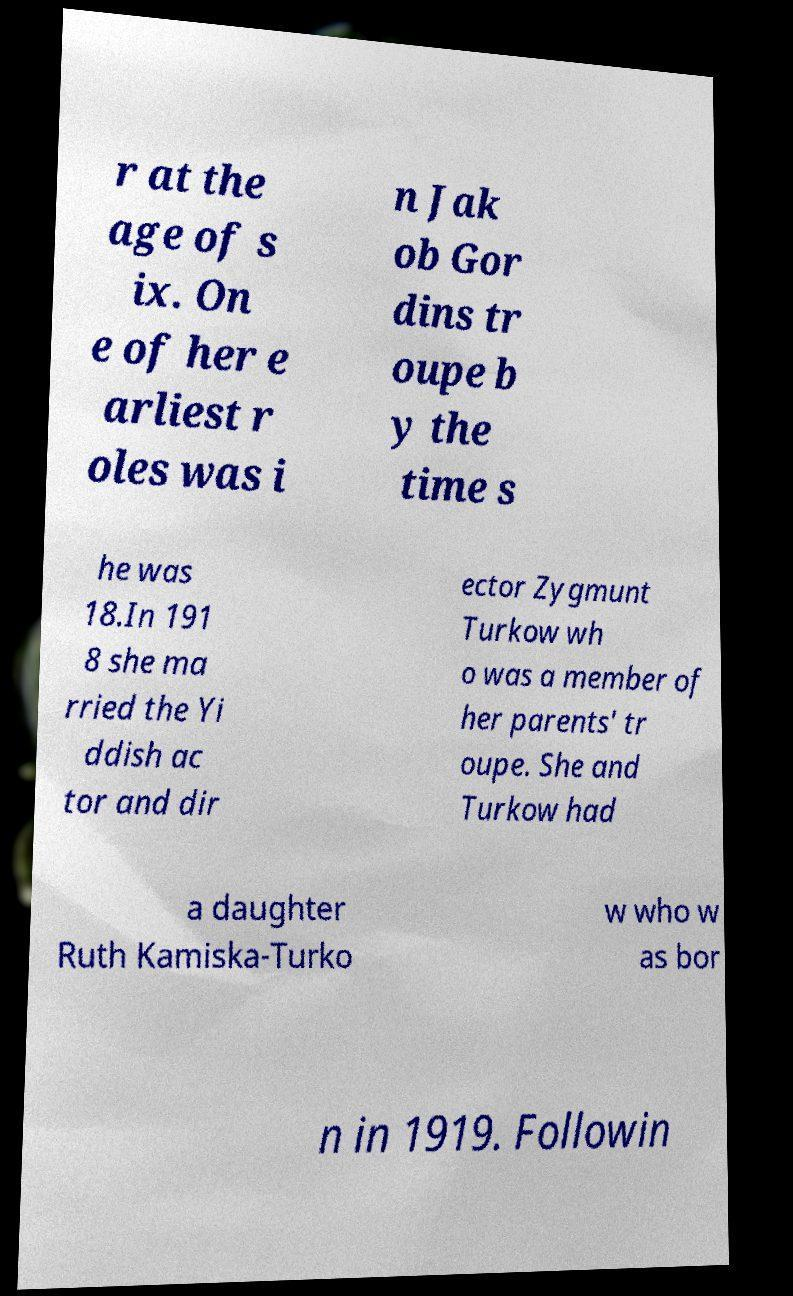Please read and relay the text visible in this image. What does it say? r at the age of s ix. On e of her e arliest r oles was i n Jak ob Gor dins tr oupe b y the time s he was 18.In 191 8 she ma rried the Yi ddish ac tor and dir ector Zygmunt Turkow wh o was a member of her parents' tr oupe. She and Turkow had a daughter Ruth Kamiska-Turko w who w as bor n in 1919. Followin 